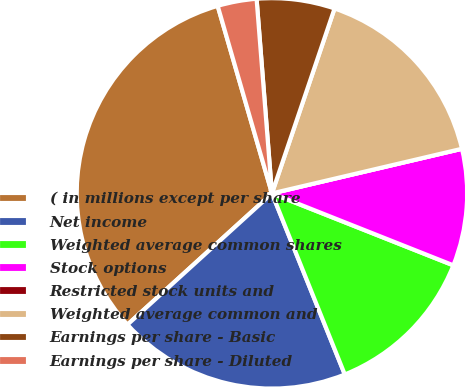Convert chart to OTSL. <chart><loc_0><loc_0><loc_500><loc_500><pie_chart><fcel>( in millions except per share<fcel>Net income<fcel>Weighted average common shares<fcel>Stock options<fcel>Restricted stock units and<fcel>Weighted average common and<fcel>Earnings per share - Basic<fcel>Earnings per share - Diluted<nl><fcel>32.25%<fcel>19.35%<fcel>12.9%<fcel>9.68%<fcel>0.0%<fcel>16.13%<fcel>6.45%<fcel>3.23%<nl></chart> 